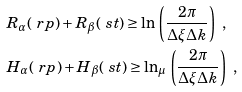Convert formula to latex. <formula><loc_0><loc_0><loc_500><loc_500>& R _ { \alpha } ( \ r p ) + R _ { \beta } ( \ s t ) \geq \ln \, \left ( \frac { 2 \pi } { \Delta \xi \Delta k } \right ) \ , \\ & H _ { \alpha } ( \ r p ) + H _ { \beta } ( \ s t ) \geq \ln _ { \mu } \, \left ( \frac { 2 \pi } { \Delta \xi \Delta k } \right ) \ ,</formula> 